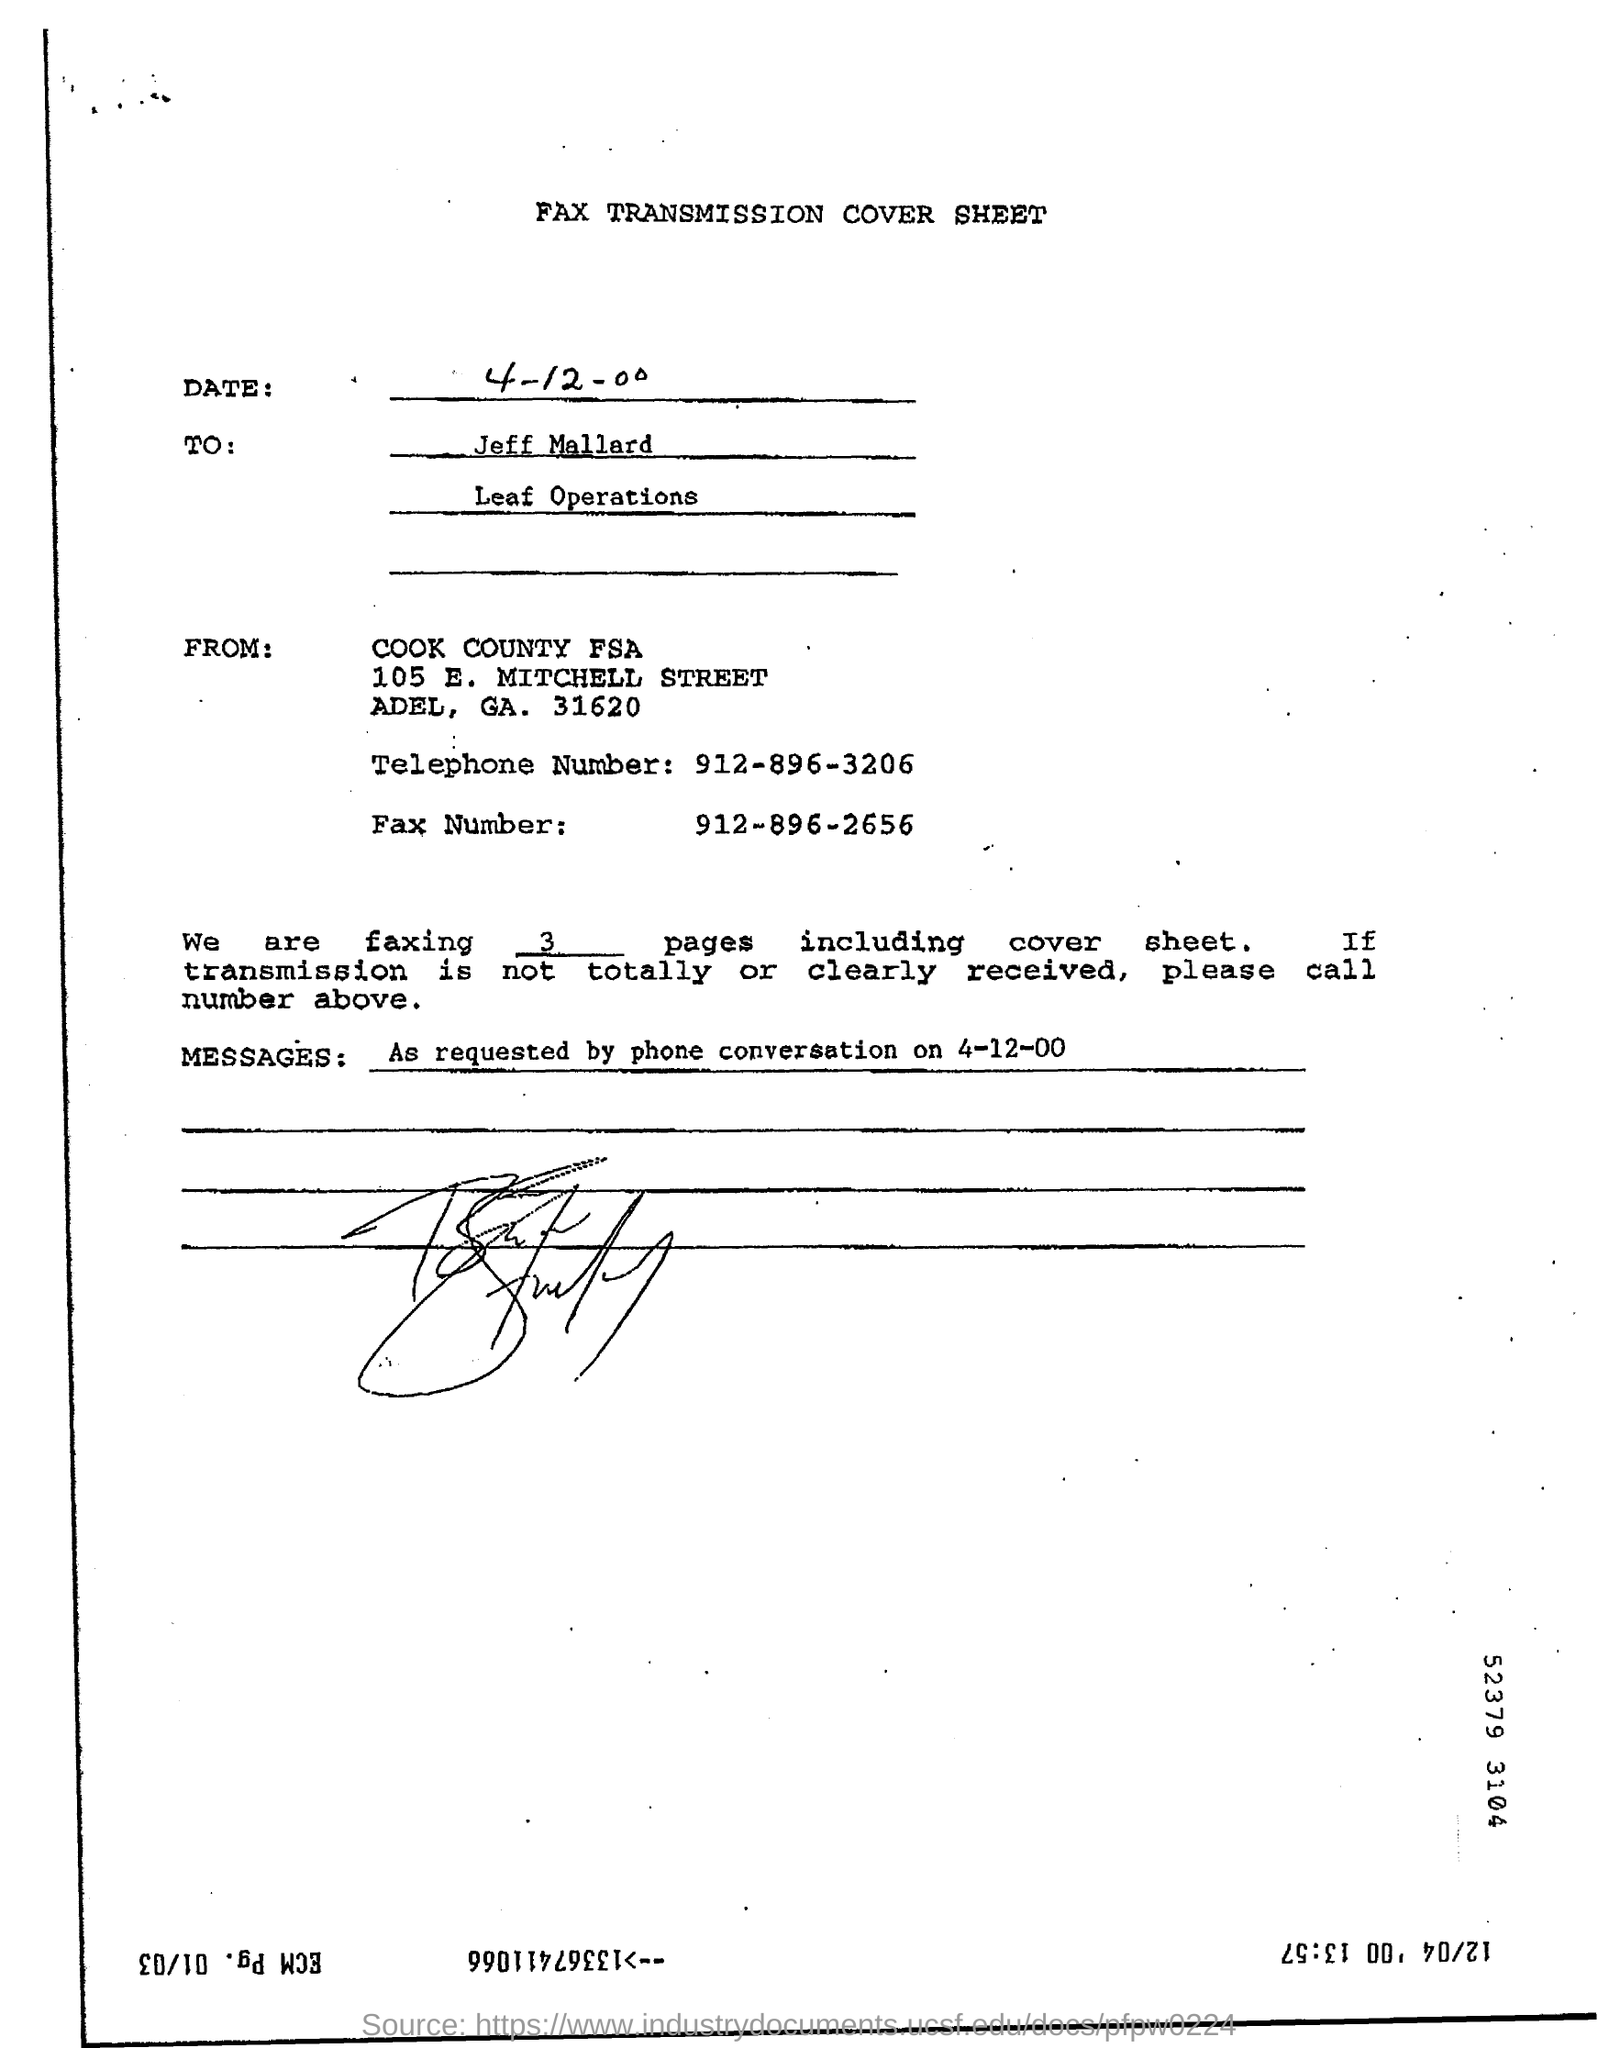What is the telephone number mentioned in the document?
Your response must be concise. 912-896-3206. What is the fax number mentioned in the document?
Give a very brief answer. 912-896-2656. How many number of pages are being faxed?
Keep it short and to the point. 3. 